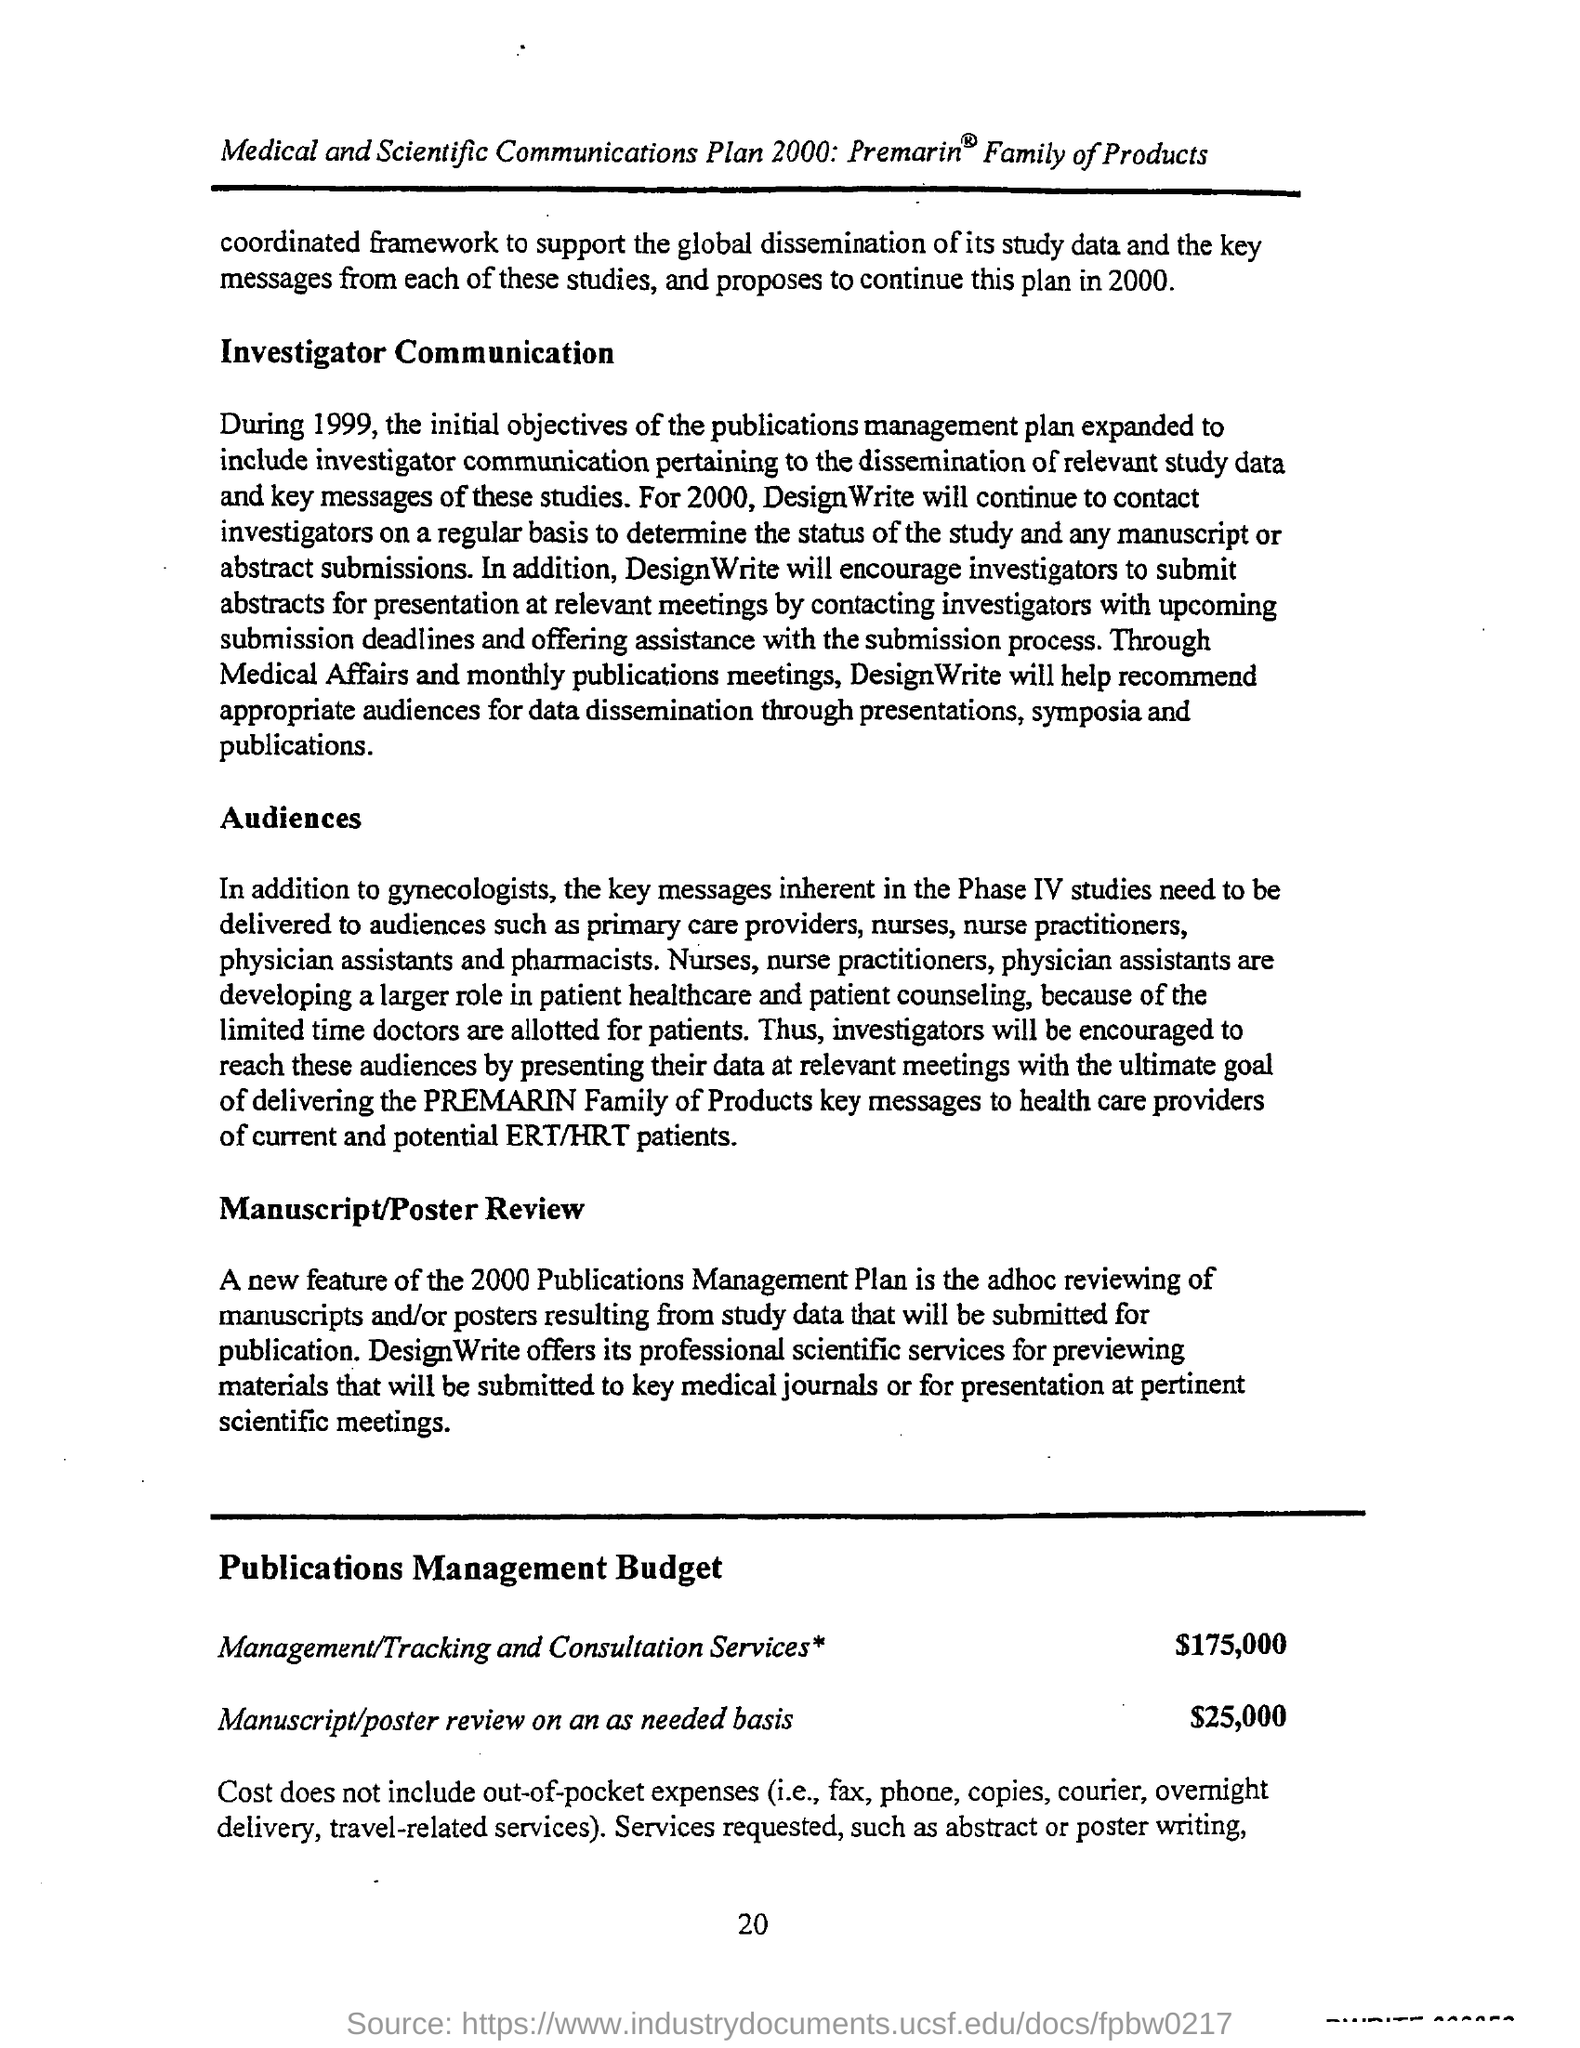What is the Budget estimate for Management/ Tracking and Consultation Services?
Provide a succinct answer. $175,000. What is the Budget Estimate for Manuscript/poster review on an as needed basis?
Make the answer very short. $25,000. What is the page no mentioned in this document?
Offer a very short reply. 20. 